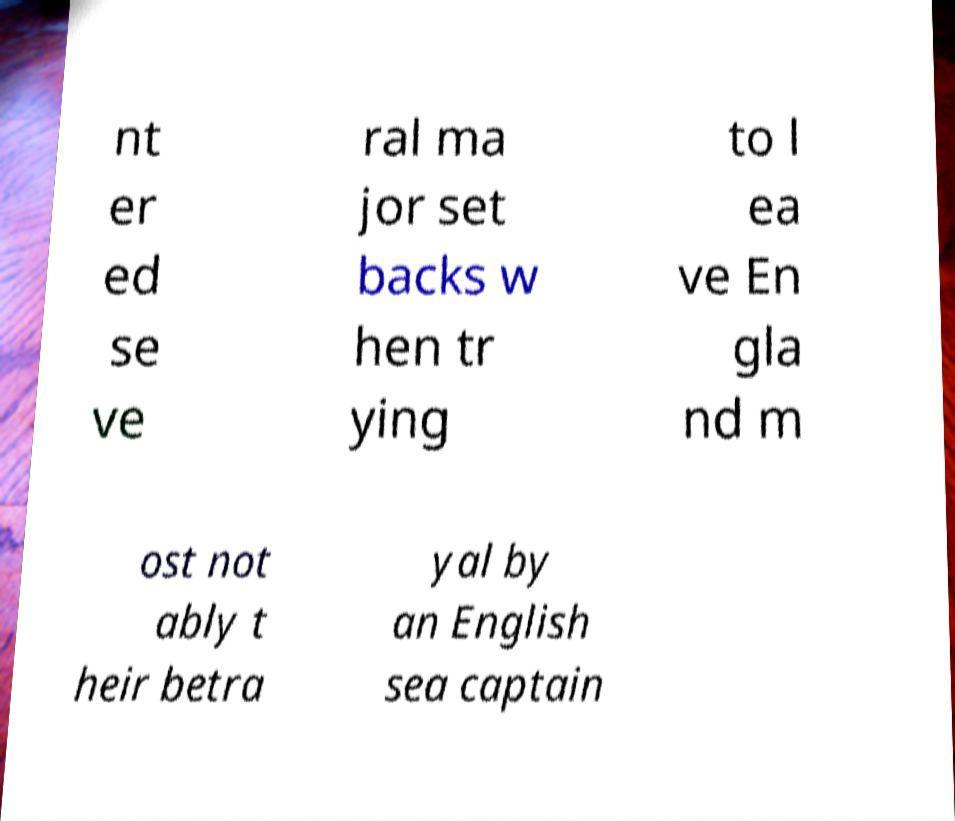Could you extract and type out the text from this image? nt er ed se ve ral ma jor set backs w hen tr ying to l ea ve En gla nd m ost not ably t heir betra yal by an English sea captain 